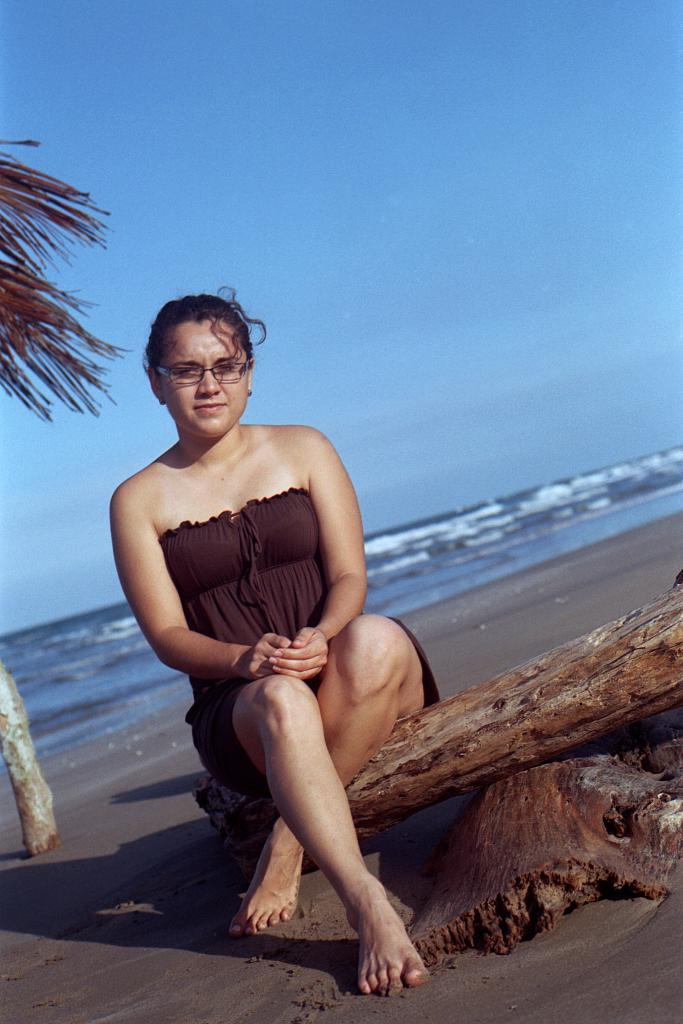Who is present in the image? There is a woman in the image. What is the woman doing in the image? The woman is sitting. What is the woman wearing in the image? The woman is wearing a brown dress. What type of environment is visible in the image? There is sand, a tree, water, and a clear sky visible in the background of the image. What invention can be seen in the woman's hand in the image? There is no invention visible in the woman's hand in the image. What type of building is present in the background of the image? There is no building present in the background of the image; it features a tree, water, and a clear sky. 